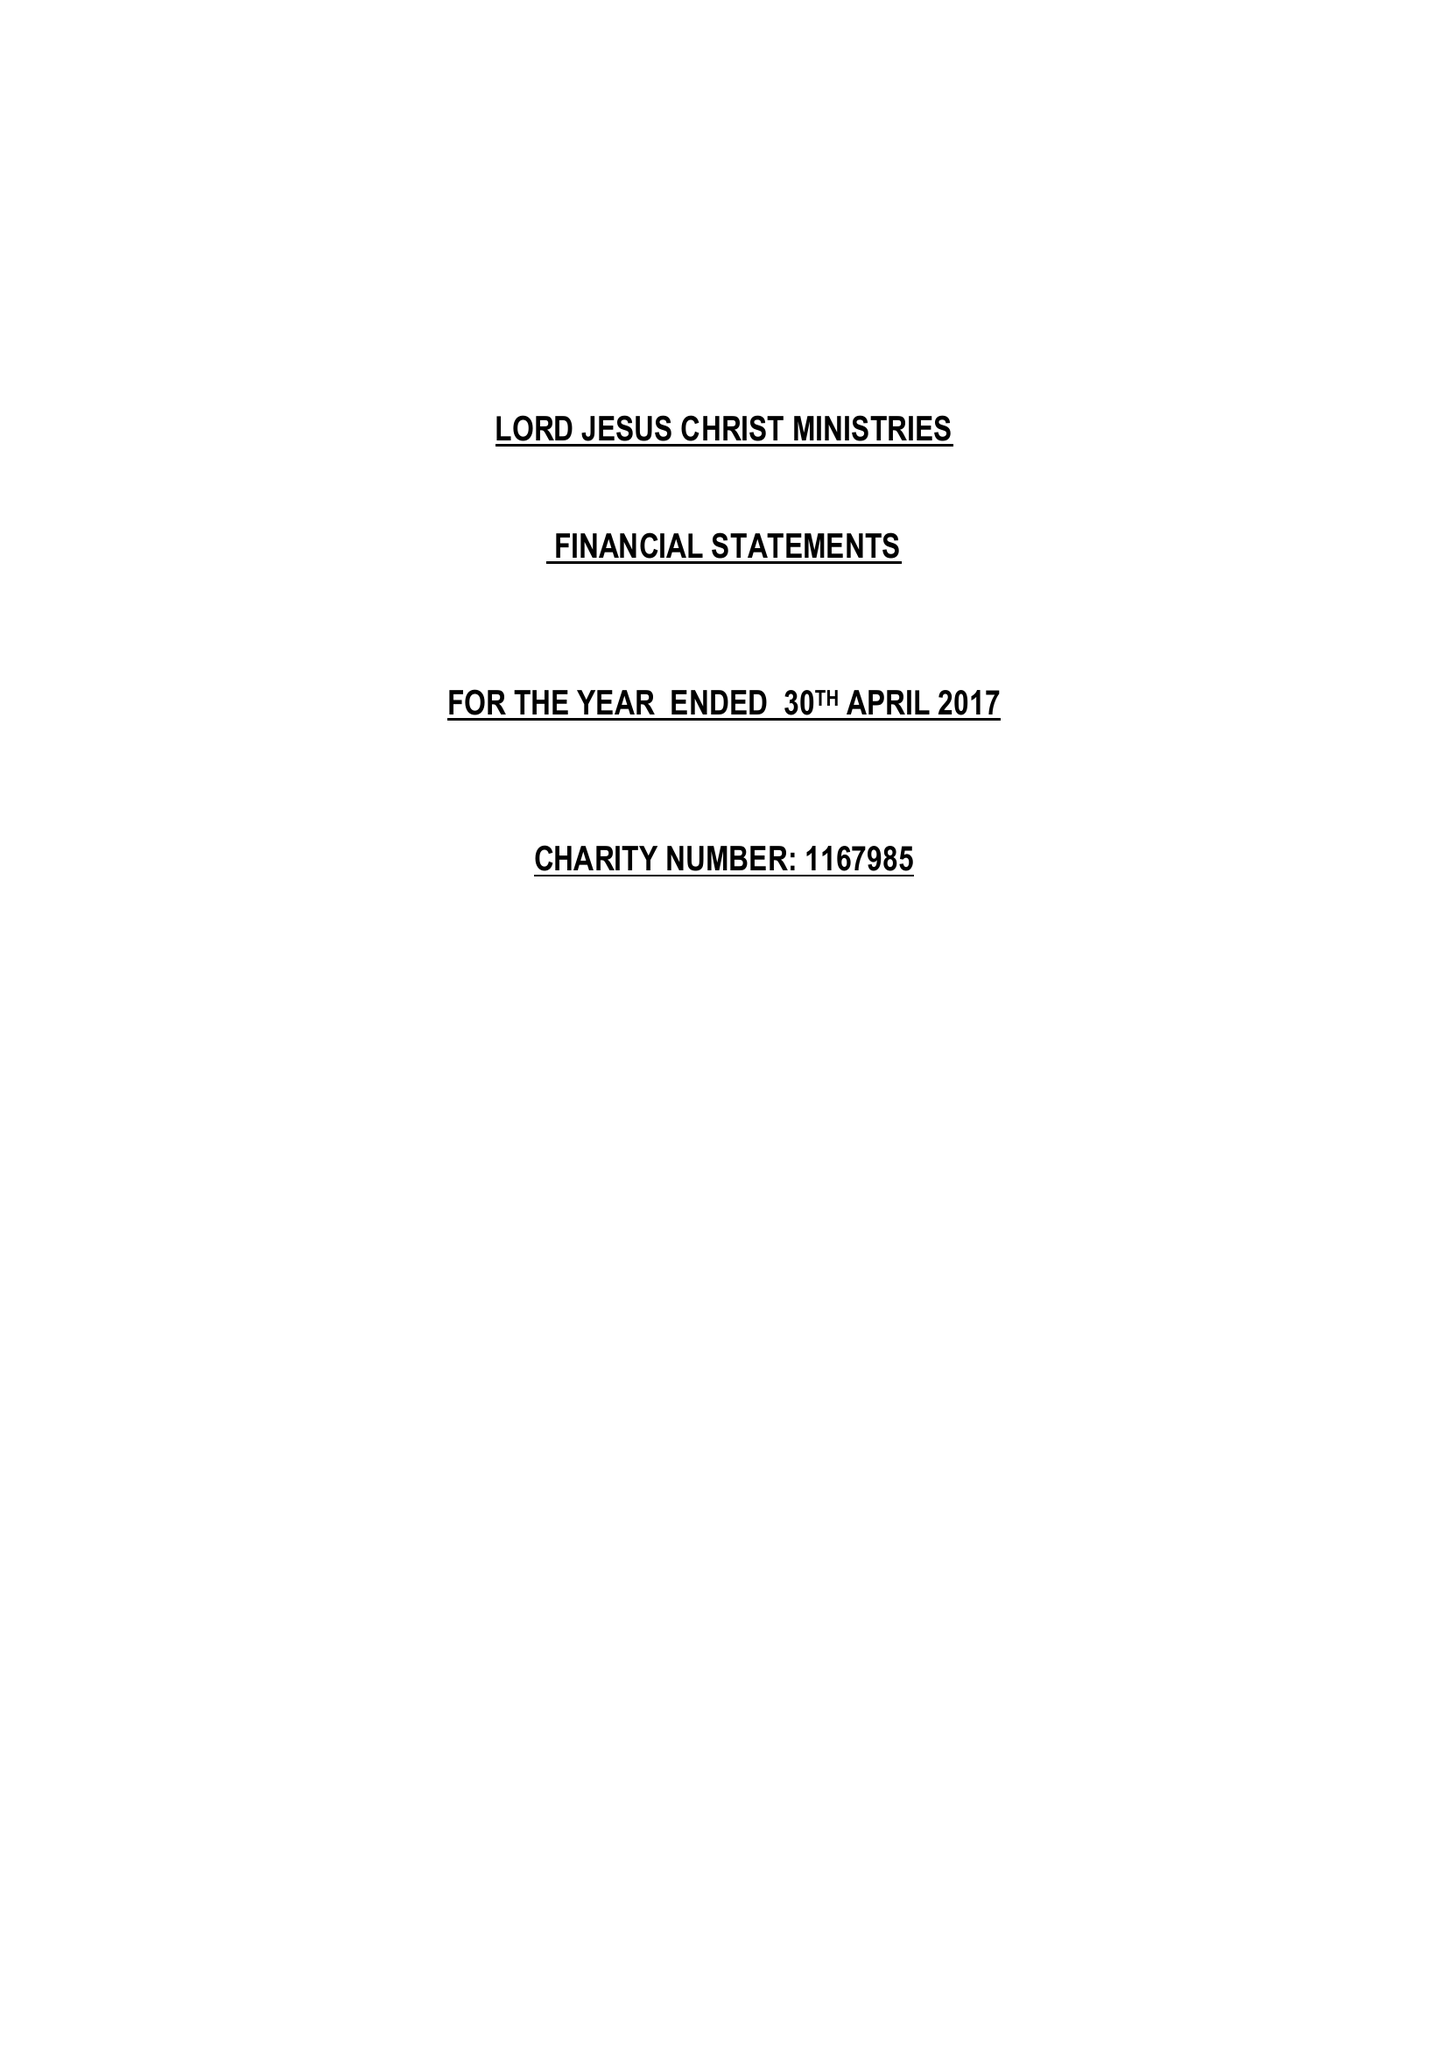What is the value for the address__street_line?
Answer the question using a single word or phrase. 59 CRUMMOCK PLACE 